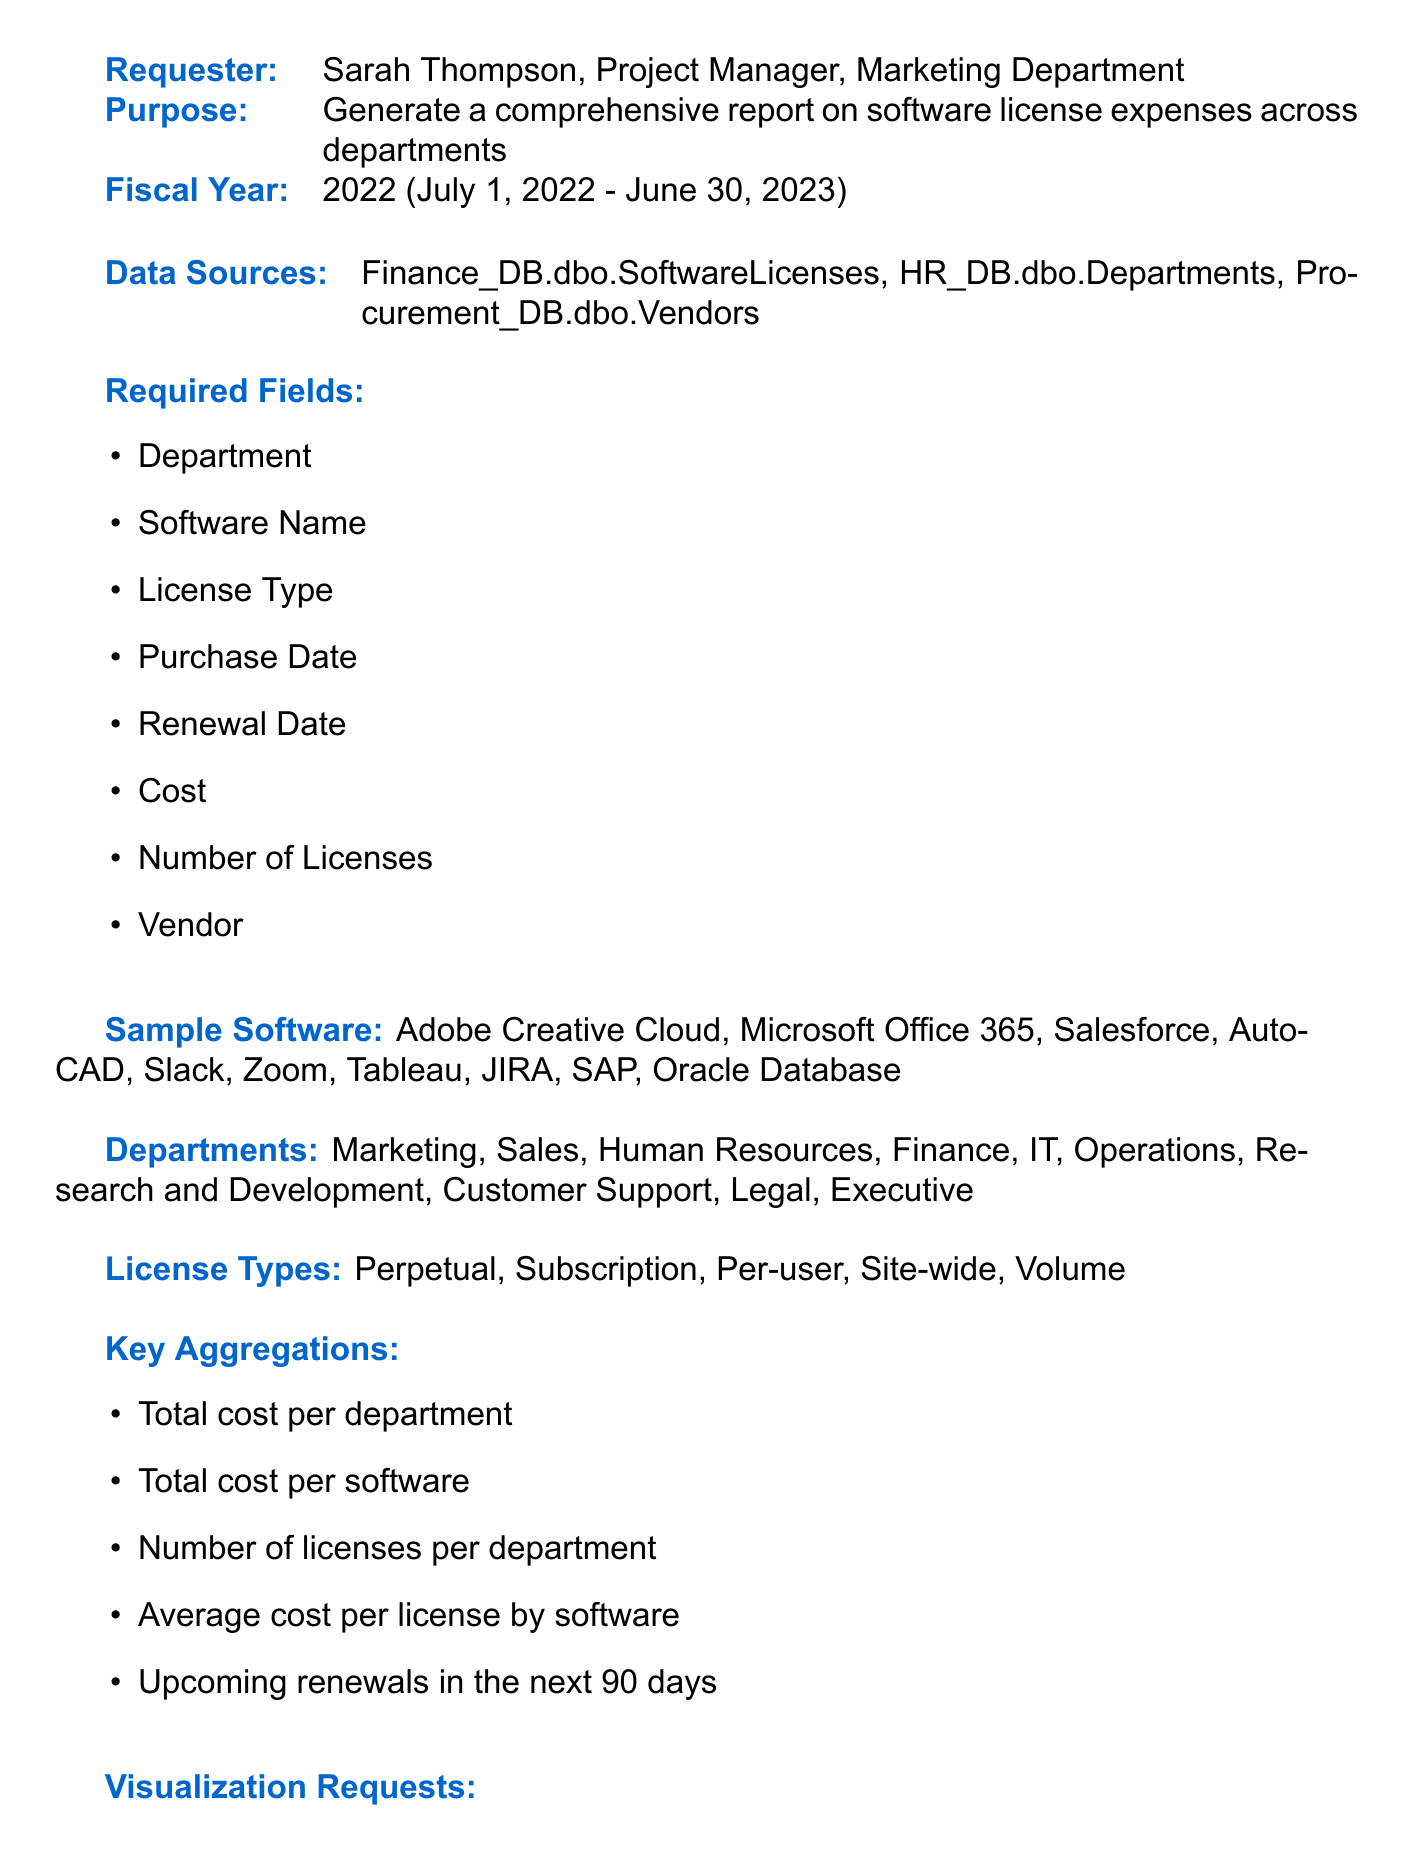What is the title of the report? The title of the report is stated at the beginning of the document.
Answer: Software License Purchases and Renewals Summary - Fiscal Year 2022 Who requested the report? The requester's name and title are provided in the document.
Answer: Sarah Thompson, Project Manager, Marketing Department What is the fiscal year covered in the report? The fiscal year is explicitly mentioned in the document.
Answer: 2022 What key data sources are used? The data sources are listed in the document.
Answer: Finance_DB.dbo.SoftwareLicenses, HR_DB.dbo.Departments, Procurement_DB.dbo.Vendors Which department has the highest number of software licenses? The answer requires reasoning through the data presented in the report.
Answer: (This would be determined from the final report and thus is not explicitly stated.) How many sheets are in the output format? The number of sheets in the output format is listed.
Answer: 4 What type of chart is requested to show total costs by department? The type of visualization requested is included in the document.
Answer: Pie chart What additional requirement flags budget excess? The specific requirement regarding budget is mentioned.
Answer: Flag departments exceeding their allocated software budget What is the purpose of the report? The purpose is stated clearly in the document.
Answer: Generate a comprehensive report on software license expenses across departments 